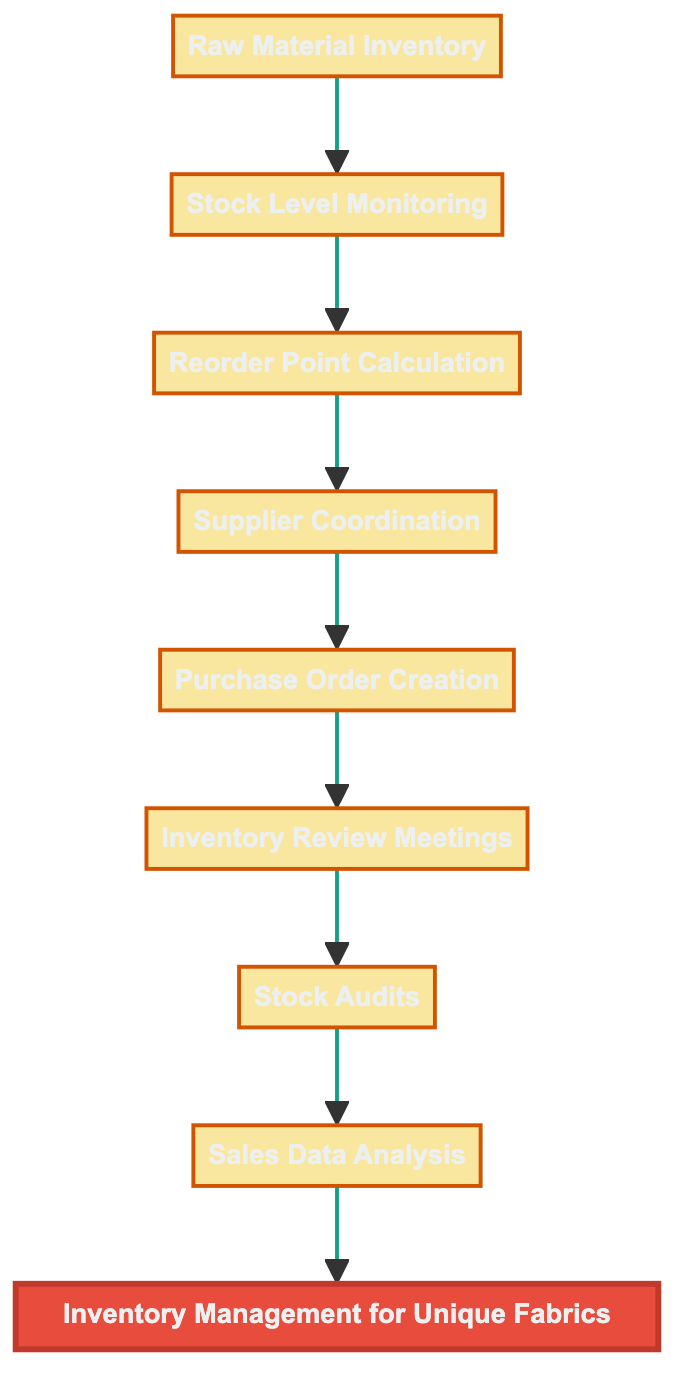What is the top node in the flowchart? The top node is labeled as "Inventory Management for Unique Fabrics". It represents the overarching process illustrated in the diagram.
Answer: Inventory Management for Unique Fabrics How many nodes are there in the diagram? Counting each listed element shows there are a total of eight nodes, ranging from raw material inventory to sales data analysis.
Answer: Eight What element comes after "Stock Level Monitoring"? The diagram shows that "Reorder Point Calculation" is directly connected to "Stock Level Monitoring", indicating it is the next step in the process flow.
Answer: Reorder Point Calculation Which two elements are connected by the edge leading to "Purchase Order Creation"? The edge leading to "Purchase Order Creation" originates from "Supplier Coordination", indicating the logical progression from coordinating with suppliers to creating purchase orders.
Answer: Supplier Coordination What is the last element in the flowchart? The final element in the flowchart is "Sales Data Analysis", which implies the review and adjustment of inventory based on sales trends.
Answer: Sales Data Analysis How does the "Inventory Review Meetings" relate to the entire diagram? "Inventory Review Meetings" function as a feedback loop, occurring after stock audits to assess and discuss the overall inventory situation, thus influencing the earlier steps.
Answer: Feedback loop Which elements are involved in the purchasing process? The elements involved in this process are "Supplier Coordination" leading to "Purchase Order Creation", indicating the steps related to acquiring new stock.
Answer: Supplier Coordination, Purchase Order Creation What is the purpose of "Stock Audits"? The purpose of "Stock Audits" is to verify that the physical fabric stock matches the recorded inventory, ensuring accuracy in inventory management.
Answer: Verify stock accuracy 